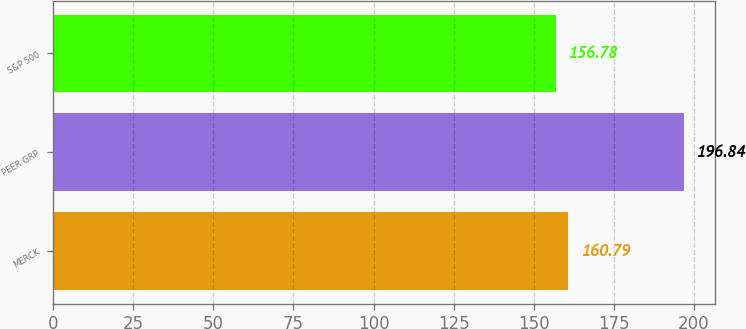<chart> <loc_0><loc_0><loc_500><loc_500><bar_chart><fcel>MERCK<fcel>PEER GRP<fcel>S&P 500<nl><fcel>160.79<fcel>196.84<fcel>156.78<nl></chart> 